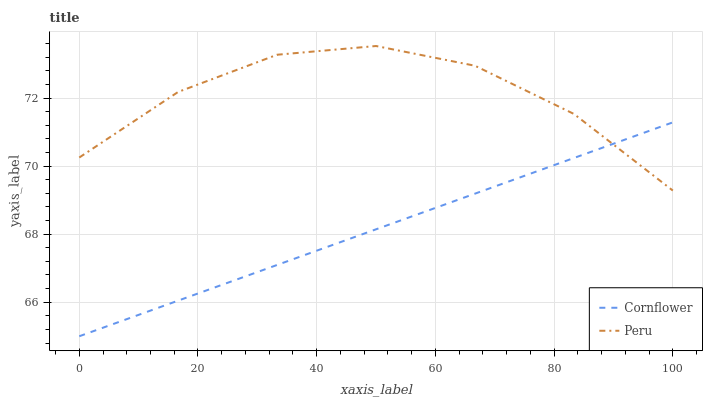Does Cornflower have the minimum area under the curve?
Answer yes or no. Yes. Does Peru have the maximum area under the curve?
Answer yes or no. Yes. Does Peru have the minimum area under the curve?
Answer yes or no. No. Is Cornflower the smoothest?
Answer yes or no. Yes. Is Peru the roughest?
Answer yes or no. Yes. Is Peru the smoothest?
Answer yes or no. No. Does Cornflower have the lowest value?
Answer yes or no. Yes. Does Peru have the lowest value?
Answer yes or no. No. Does Peru have the highest value?
Answer yes or no. Yes. Does Peru intersect Cornflower?
Answer yes or no. Yes. Is Peru less than Cornflower?
Answer yes or no. No. Is Peru greater than Cornflower?
Answer yes or no. No. 